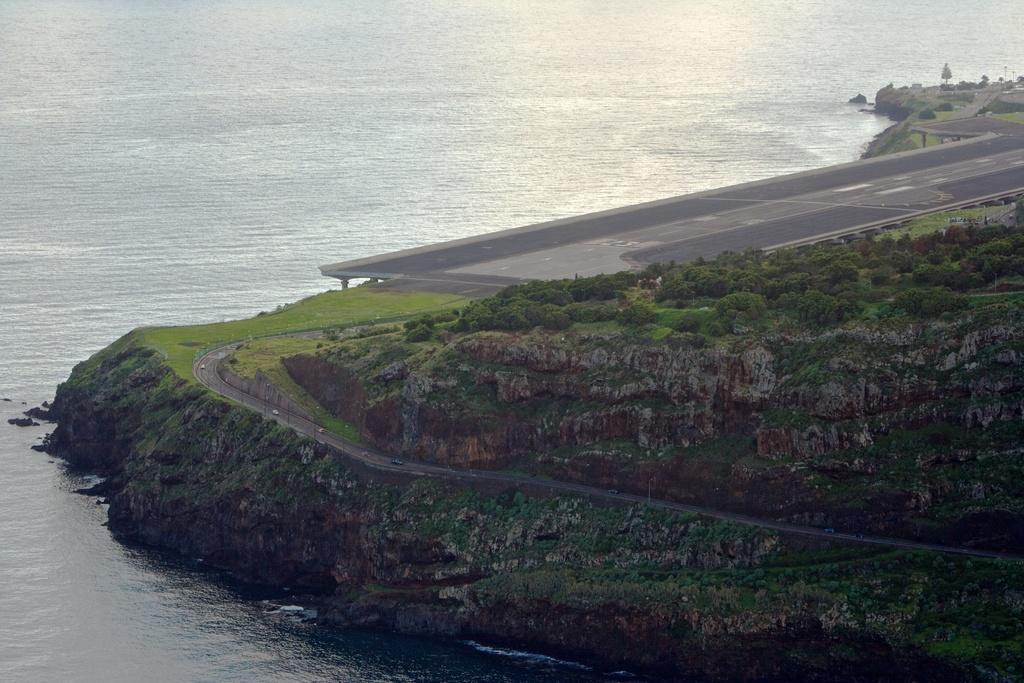Please provide a concise description of this image. In this picture there is water at the top side of the image and there is greenery on the right side of the image. 